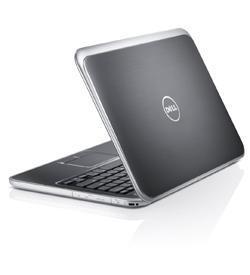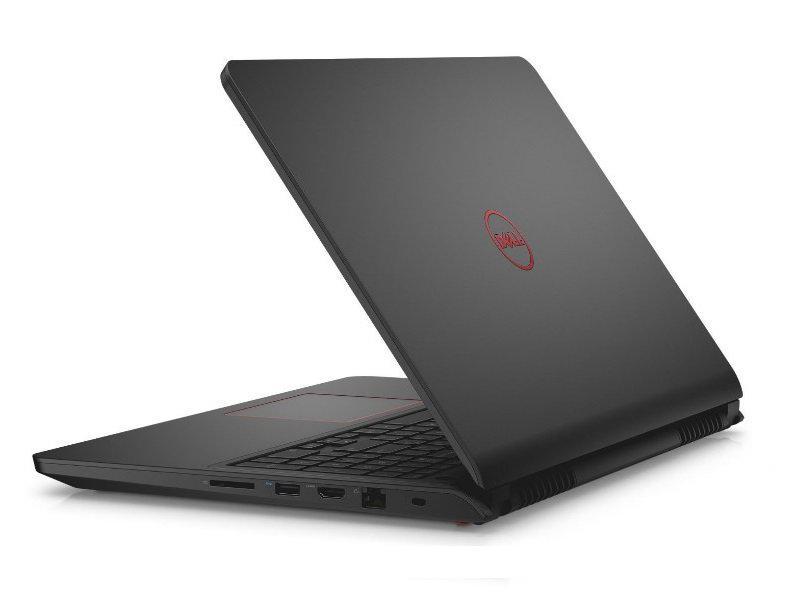The first image is the image on the left, the second image is the image on the right. For the images shown, is this caption "All laptops are opened at less than a 90-degree angle, and at least one laptop has its back turned toward the camera." true? Answer yes or no. Yes. The first image is the image on the left, the second image is the image on the right. Assess this claim about the two images: "One of images shows a laptop with the keyboard facing forward and the other image shows a laptop with the keyboard at an angle.". Correct or not? Answer yes or no. No. 